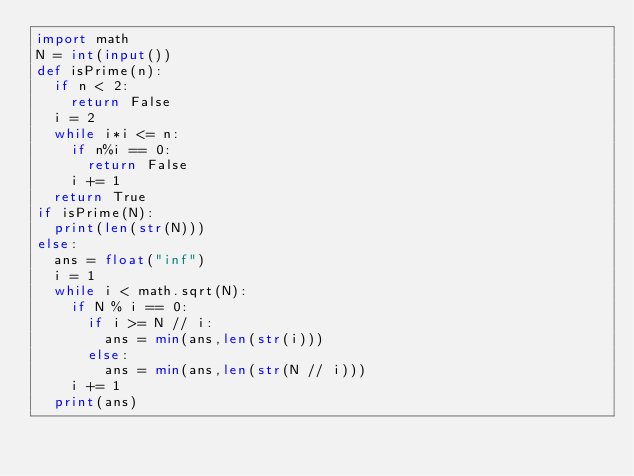<code> <loc_0><loc_0><loc_500><loc_500><_Python_>import math
N = int(input())
def isPrime(n):
  if n < 2:
    return False
  i = 2
  while i*i <= n:
    if n%i == 0:
      return False
    i += 1
  return True
if isPrime(N):
  print(len(str(N)))
else:
  ans = float("inf")
  i = 1
  while i < math.sqrt(N):
    if N % i == 0:
      if i >= N // i:
        ans = min(ans,len(str(i)))
      else:
        ans = min(ans,len(str(N // i)))
    i += 1
  print(ans)    </code> 